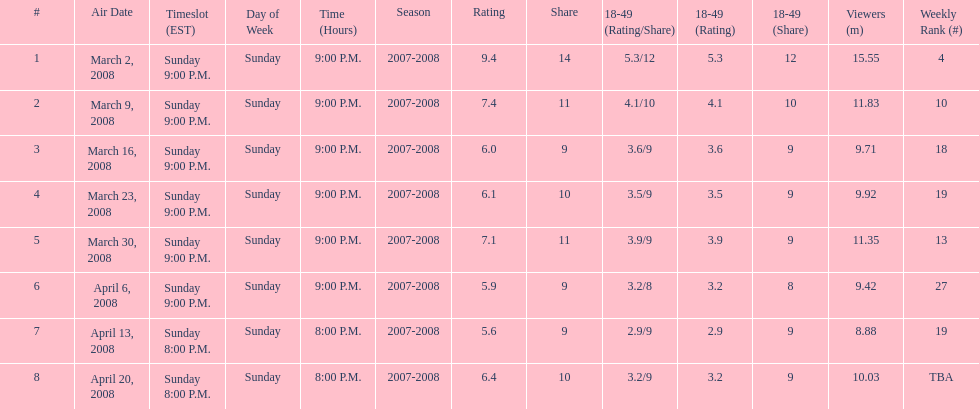Which air date had the least viewers? April 13, 2008. 